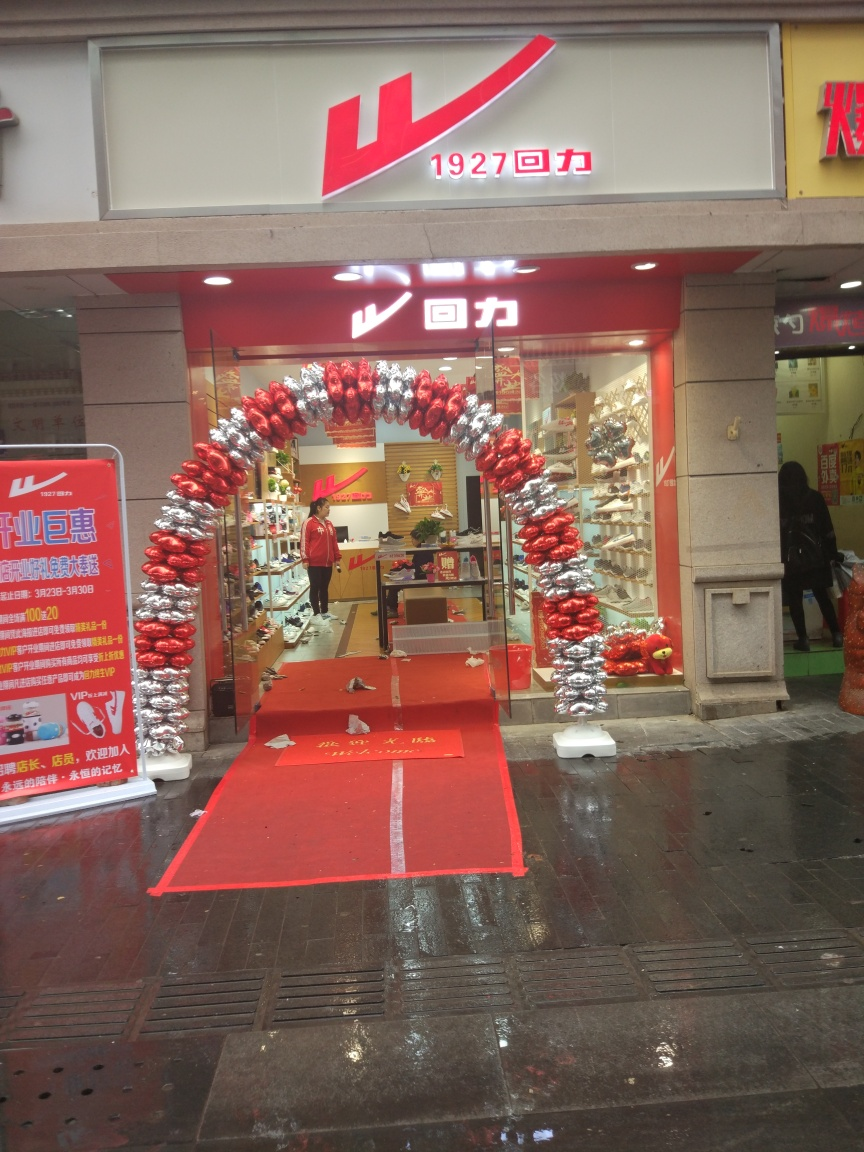Can you describe the decoration at the entrance of the store? The entrance of the store is adorned with a festive archway made of alternating red and silver metallic balloons, which suggests a celebratory event or promotion might be happening. 